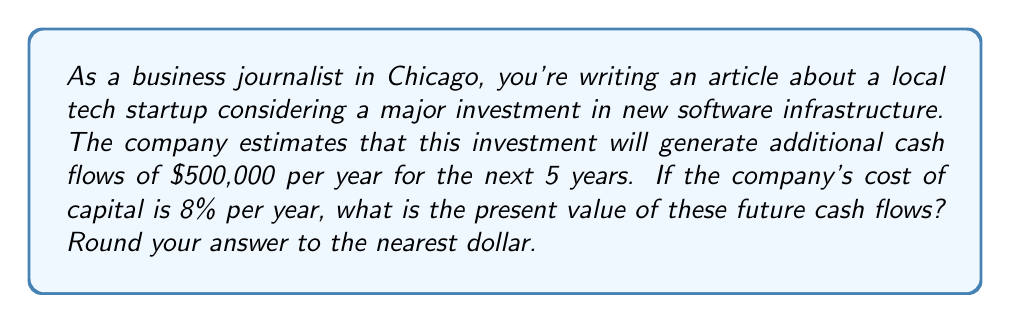Solve this math problem. To solve this problem, we need to use the present value formula for an annuity, as we're dealing with equal cash flows over a fixed period. The formula is:

$$PV = \frac{CF}{r} \left(1 - \frac{1}{(1+r)^n}\right)$$

Where:
$PV$ = Present Value
$CF$ = Annual Cash Flow
$r$ = Discount Rate (Cost of Capital)
$n$ = Number of Periods

Given:
$CF = \$500,000$
$r = 8\% = 0.08$
$n = 5$ years

Let's substitute these values into the formula:

$$PV = \frac{500,000}{0.08} \left(1 - \frac{1}{(1+0.08)^5}\right)$$

Now, let's solve step by step:

1) First, calculate $(1+0.08)^5$:
   $(1.08)^5 = 1.469328$

2) Then, calculate $\frac{1}{1.469328}$:
   $\frac{1}{1.469328} = 0.680583$

3) Now, subtract this from 1:
   $1 - 0.680583 = 0.319417$

4) Multiply by $\frac{500,000}{0.08}$:
   $\frac{500,000}{0.08} = 6,250,000$
   $6,250,000 * 0.319417 = 1,996,356.25$

5) Round to the nearest dollar:
   $1,996,356$

Therefore, the present value of the future cash flows is $1,996,356.
Answer: $1,996,356 